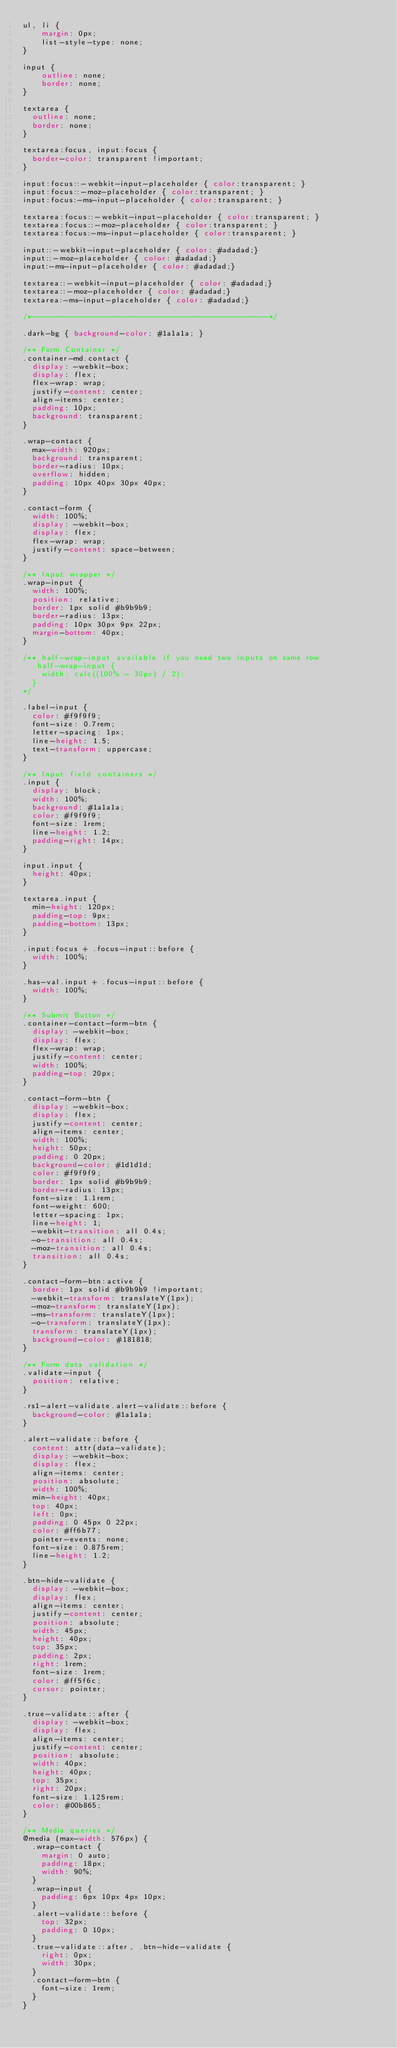<code> <loc_0><loc_0><loc_500><loc_500><_CSS_>ul, li {
	margin: 0px;
	list-style-type: none;
}

input {
	outline: none;
	border: none;
}

textarea {
  outline: none;
  border: none;
}

textarea:focus, input:focus {
  border-color: transparent !important;
}

input:focus::-webkit-input-placeholder { color:transparent; }
input:focus::-moz-placeholder { color:transparent; }
input:focus:-ms-input-placeholder { color:transparent; }

textarea:focus::-webkit-input-placeholder { color:transparent; }
textarea:focus::-moz-placeholder { color:transparent; }
textarea:focus:-ms-input-placeholder { color:transparent; }

input::-webkit-input-placeholder { color: #adadad;}
input::-moz-placeholder { color: #adadad;}
input:-ms-input-placeholder { color: #adadad;}

textarea::-webkit-input-placeholder { color: #adadad;}
textarea::-moz-placeholder { color: #adadad;}
textarea:-ms-input-placeholder { color: #adadad;}

/*---------------------------------------------------*/

.dark-bg { background-color: #1a1a1a; }

/** Form Container */
.container-md.contact {
  display: -webkit-box;
  display: flex;
  flex-wrap: wrap;
  justify-content: center;
  align-items: center;
  padding: 10px;
  background: transparent;
}

.wrap-contact {
  max-width: 920px;
  background: transparent;
  border-radius: 10px;
  overflow: hidden;
  padding: 10px 40px 30px 40px;
}

.contact-form {
  width: 100%;
  display: -webkit-box;
  display: flex;
  flex-wrap: wrap;
  justify-content: space-between;
}

/** Input wrapper */
.wrap-input {
  width: 100%;
  position: relative;
  border: 1px solid #b9b9b9;
  border-radius: 13px;
  padding: 10px 30px 9px 22px;
  margin-bottom: 40px;
}

/** half-wrap-input available if you need two inputs on same row
  .half-wrap-input {
    width: calc((100% - 30px) / 2);
  } 
*/

.label-input {
  color: #f9f9f9;
  font-size: 0.7rem;
  letter-spacing: 1px;
  line-height: 1.5;
  text-transform: uppercase;
}

/** Input field containers */
.input {
  display: block;
  width: 100%;
  background: #1a1a1a;
  color: #f9f9f9;
  font-size: 1rem;
  line-height: 1.2;
  padding-right: 14px;
}

input.input {
  height: 40px;
}

textarea.input {
  min-height: 120px;
  padding-top: 9px;
  padding-bottom: 13px;
}

.input:focus + .focus-input::before {
  width: 100%;
}

.has-val.input + .focus-input::before {
  width: 100%;
}

/** Submit Button */
.container-contact-form-btn {
  display: -webkit-box;
  display: flex;
  flex-wrap: wrap;
  justify-content: center;
  width: 100%;
  padding-top: 20px;
}

.contact-form-btn {
  display: -webkit-box;
  display: flex;
  justify-content: center;
  align-items: center;
  width: 100%;
  height: 50px;
  padding: 0 20px;
  background-color: #1d1d1d;
  color: #f9f9f9;
  border: 1px solid #b9b9b9;
  border-radius: 13px;
  font-size: 1.1rem;
  font-weight: 600;
  letter-spacing: 1px;
  line-height: 1;
  -webkit-transition: all 0.4s;
  -o-transition: all 0.4s;
  -moz-transition: all 0.4s;
  transition: all 0.4s;
}

.contact-form-btn:active {
  border: 1px solid #b9b9b9 !important;
  -webkit-transform: translateY(1px);
  -moz-transform: translateY(1px);
  -ms-transform: translateY(1px);
  -o-transform: translateY(1px);
  transform: translateY(1px);
  background-color: #181818;
}

/** Form data validation */
.validate-input {
  position: relative;
}

.rs1-alert-validate.alert-validate::before {
  background-color: #1a1a1a;
}

.alert-validate::before {
  content: attr(data-validate);
  display: -webkit-box;
  display: flex;
  align-items: center;
  position: absolute;
  width: 100%;
  min-height: 40px;
  top: 40px;
  left: 0px;
  padding: 0 45px 0 22px;
  color: #ff6b77;
  pointer-events: none;
  font-size: 0.875rem;
  line-height: 1.2;
}

.btn-hide-validate {
  display: -webkit-box;
  display: flex;
  align-items: center;
  justify-content: center;
  position: absolute;
  width: 45px;
  height: 40px;
  top: 35px;
  padding: 2px;
  right: 1rem;
  font-size: 1rem;
  color: #ff5f6c;
  cursor: pointer;
}

.true-validate::after {
  display: -webkit-box;
  display: flex;
  align-items: center;
  justify-content: center;
  position: absolute;
  width: 40px;
  height: 40px;
  top: 35px;
  right: 20px;
  font-size: 1.125rem;
  color: #00b865;
}

/** Media queries */
@media (max-width: 576px) {
  .wrap-contact {
    margin: 0 auto;
    padding: 18px;
    width: 90%;
  }
  .wrap-input {
    padding: 6px 10px 4px 10px;
  }
  .alert-validate::before {
    top: 32px;
    padding: 0 10px;
  }
  .true-validate::after, .btn-hide-validate {
    right: 0px;
    width: 30px;
  }
  .contact-form-btn {
    font-size: 1rem;
  }
}
</code> 